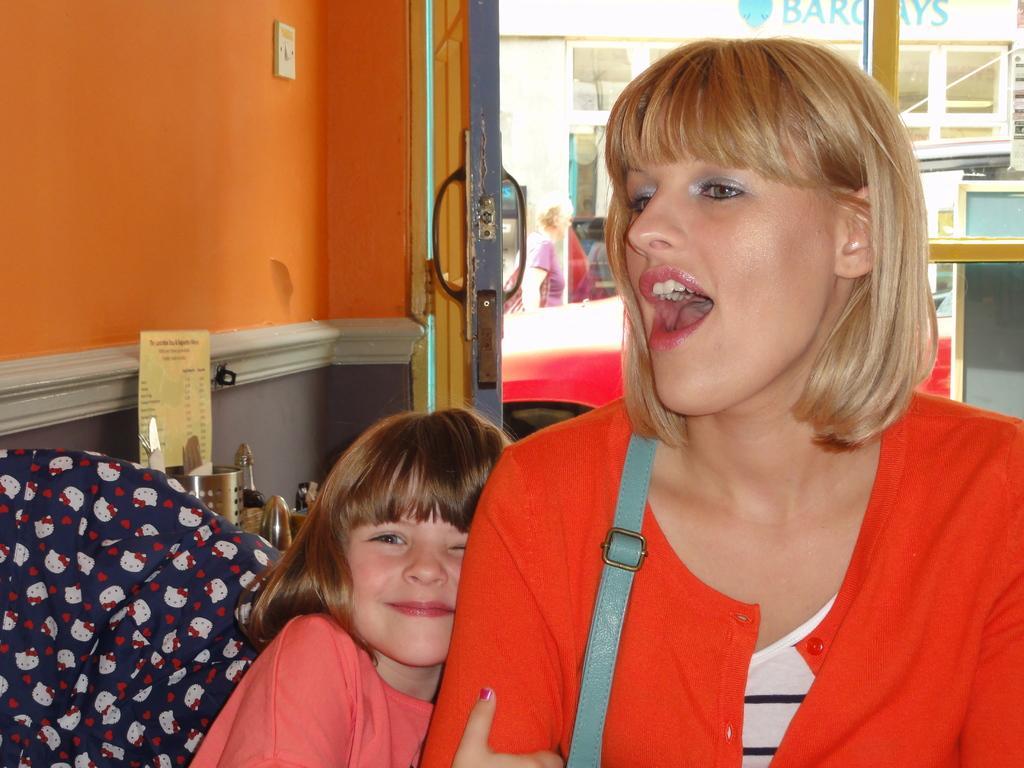Describe this image in one or two sentences. On the right side of the image a lady is wearing bag and shouting. In the center of the image a girl is holding a lady. In the background of the image we can see the wall, some objects, board, door, glass, a lady, store. 